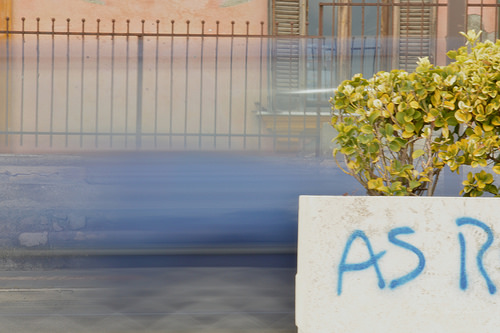<image>
Is the bush next to the sign? No. The bush is not positioned next to the sign. They are located in different areas of the scene. 